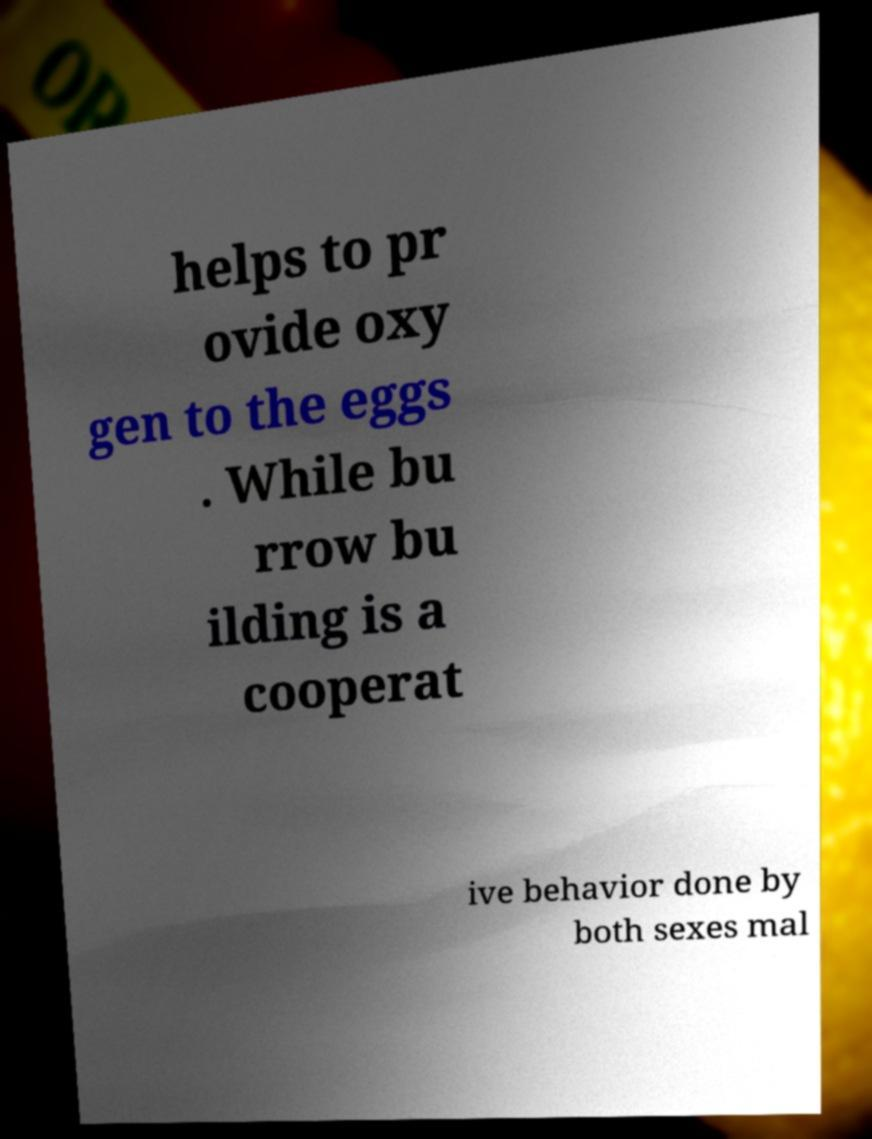Could you assist in decoding the text presented in this image and type it out clearly? helps to pr ovide oxy gen to the eggs . While bu rrow bu ilding is a cooperat ive behavior done by both sexes mal 